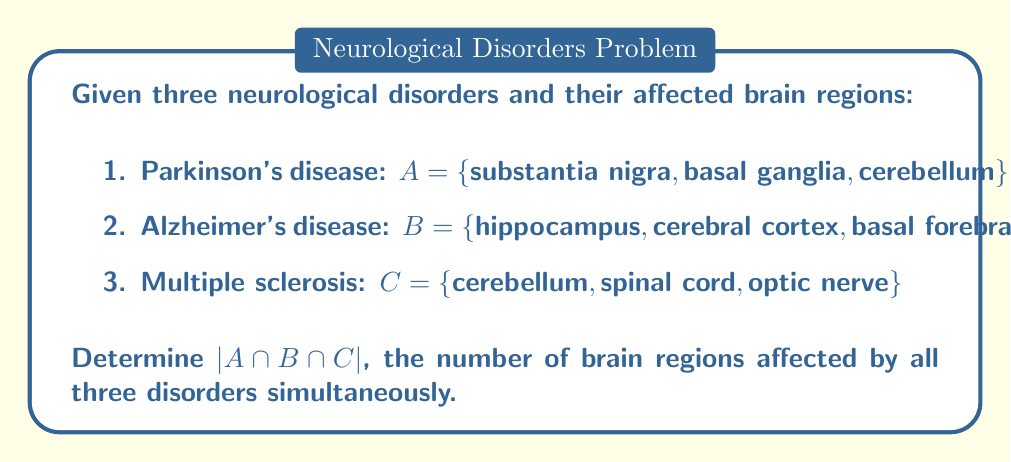Teach me how to tackle this problem. To solve this problem, we need to follow these steps:

1. Identify the sets:
   $A = \{substantia\ nigra, basal\ ganglia, cerebellum\}$
   $B = \{hippocampus, cerebral\ cortex, basal\ forebrain\}$
   $C = \{cerebellum, spinal\ cord, optic\ nerve\}$

2. Find the intersection of all three sets:
   $A \cap B \cap C = \{x : x \in A \text{ and } x \in B \text{ and } x \in C\}$

3. Compare the elements of each set to find common elements:
   - The only element that appears in all three sets is "cerebellum"

4. Count the number of elements in the intersection:
   $|A \cap B \cap C| = 1$

This result indicates that among the given brain regions affected by Parkinson's disease, Alzheimer's disease, and Multiple sclerosis, only the cerebellum is common to all three disorders.

For a neurologist, this information is crucial as it highlights the importance of the cerebellum in these neurological disorders. It suggests that cerebellar dysfunction might be a common factor in these conditions, which could have implications for diagnosis, treatment, and research strategies.
Answer: $|A \cap B \cap C| = 1$ 